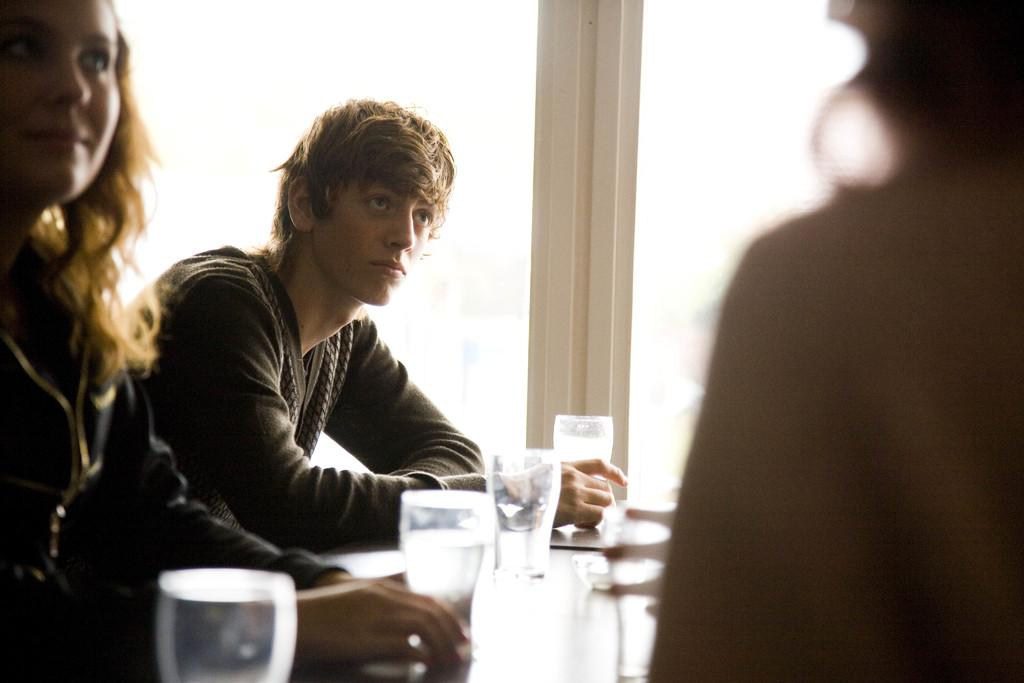How many people are sitting in chairs in the image? There are two persons sitting in chairs in the image. What is located in front of the two persons? There is a table in front of the two persons. What can be seen on the table? There is a glass of water on the table. Can you describe the person in the right corner of the image? There is another person in the right corner of the image. What is the writer working on in the image? There is no writer present in the image, and therefore no writing activity can be observed. 